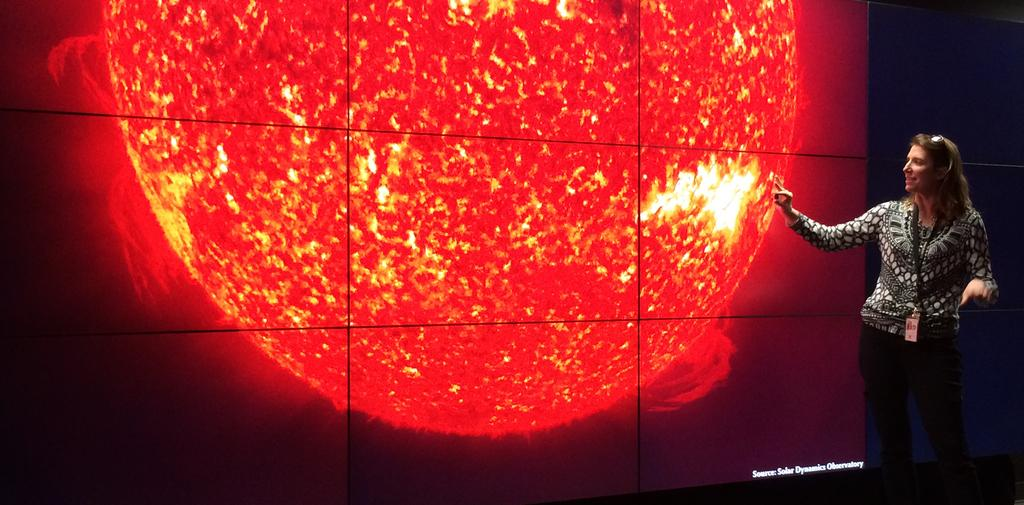What is the person in the image doing? The person is standing and pointing towards a screen. What can be seen on the screen? There is an image on the screen. Is there any text visible on the screen? Yes, there is text in the right bottom corner of the screen. What type of quartz can be seen on the person's shoulder in the image? There is no quartz visible on the person's shoulder in the image. Can you see a giraffe in the image? No, there is no giraffe present in the image. 